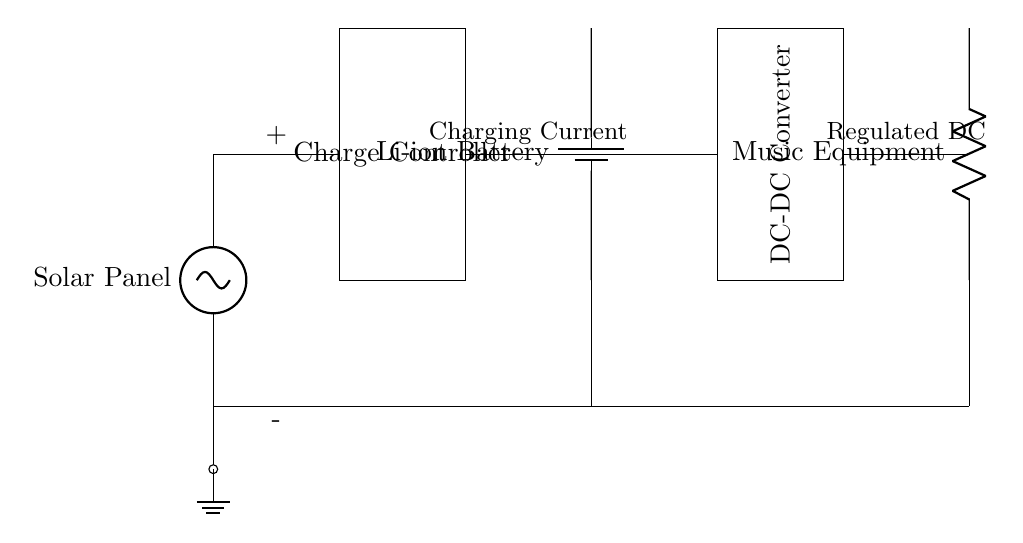What is the primary energy source in this circuit? The primary energy source is the solar panel, which is the first component in the circuit that converts sunlight into electrical energy.
Answer: Solar Panel What type of battery is used? The circuit shows a lithium-ion battery, which is commonly used for its recharging capability and energy density.
Answer: Li-ion Battery What does the charge controller do in this circuit? The charge controller regulates voltage and current flowing from the solar panel to the battery, preventing overcharging and damage.
Answer: Regulates charging What is the function of the DC-DC converter? The DC-DC converter's role is to adjust the voltage to a suitable level for the music equipment, ensuring it receives the correct power.
Answer: Voltage adjustment How is the circuit grounded? The circuit is grounded via a connection at the bottom, linking the solar panel, battery, and load to a common ground point for safety.
Answer: Common Ground What is the load in this circuit? The load in the circuit is the music equipment, which draws power from the battery to operate.
Answer: Music Equipment What voltage does the charging current represent? The charging current is not explicitly labeled with a value, but it indicates the current flowing to the battery during charging, recommended to be a managed value by the circuit’s components.
Answer: Charging Current 